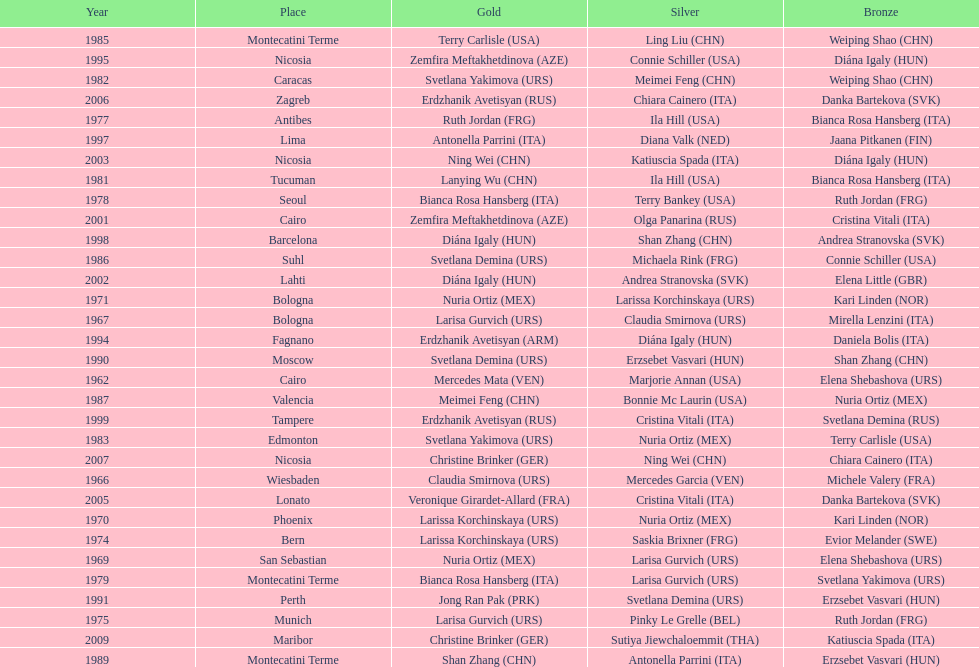Which country has the most bronze medals? Italy. 